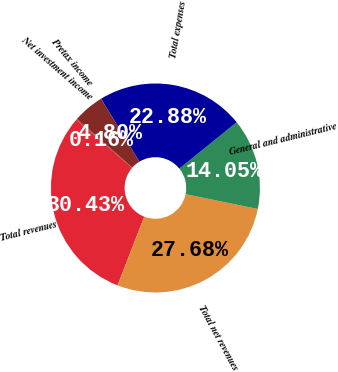Convert chart to OTSL. <chart><loc_0><loc_0><loc_500><loc_500><pie_chart><fcel>Net investment income<fcel>Total revenues<fcel>Total net revenues<fcel>General and administrative<fcel>Total expenses<fcel>Pretax income<nl><fcel>0.16%<fcel>30.43%<fcel>27.68%<fcel>14.05%<fcel>22.88%<fcel>4.8%<nl></chart> 